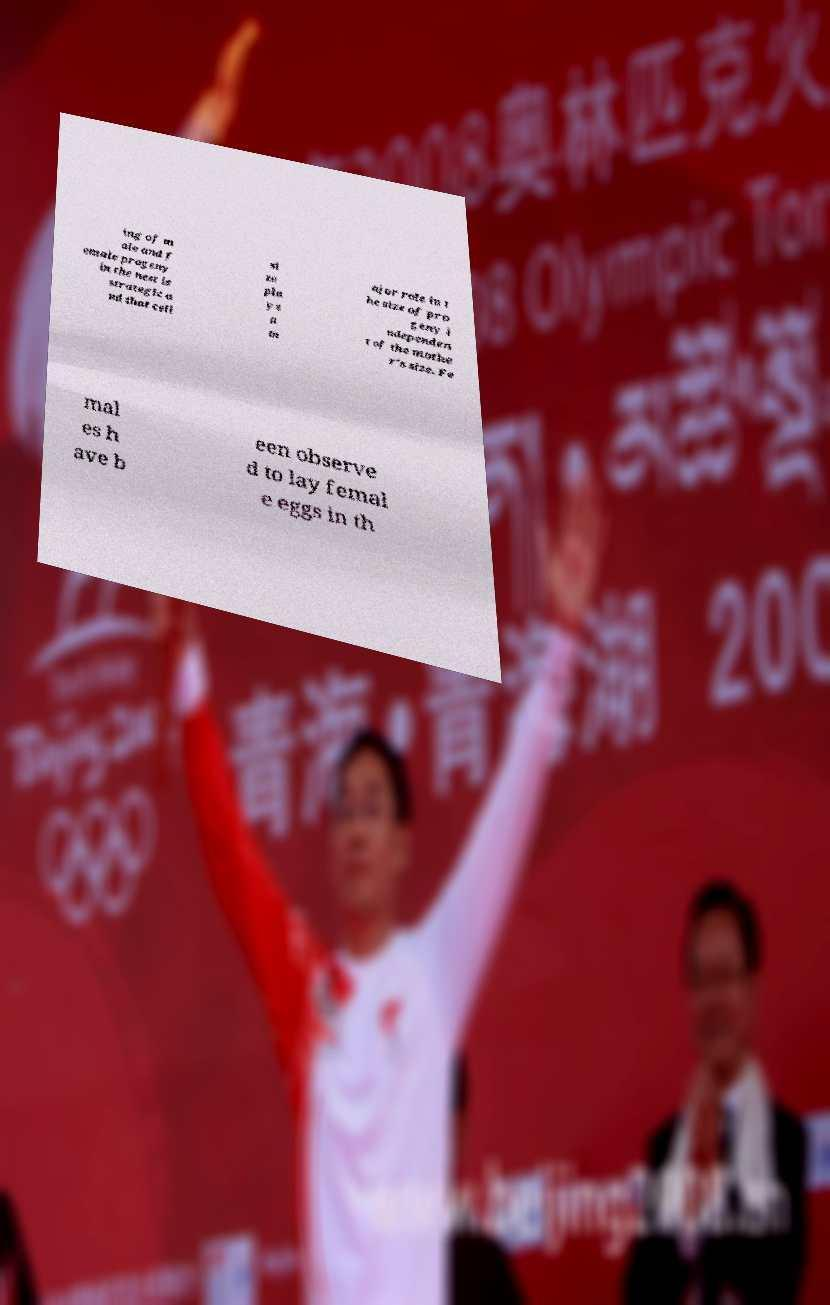Can you read and provide the text displayed in the image?This photo seems to have some interesting text. Can you extract and type it out for me? ing of m ale and f emale progeny in the nest is strategic a nd that cell si ze pla ys a m ajor role in t he size of pro geny i ndependen t of the mothe r's size. Fe mal es h ave b een observe d to lay femal e eggs in th 